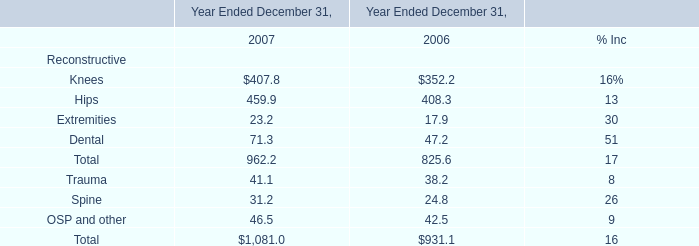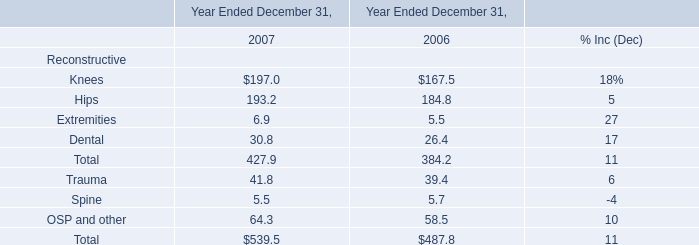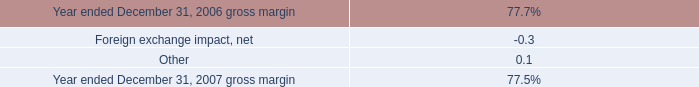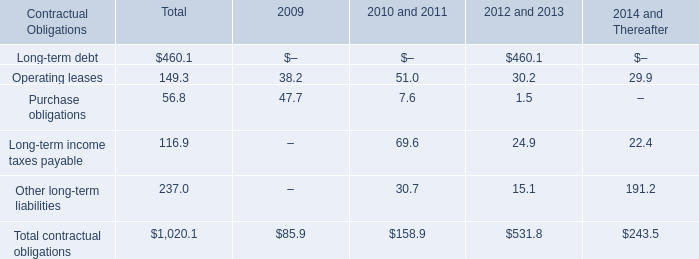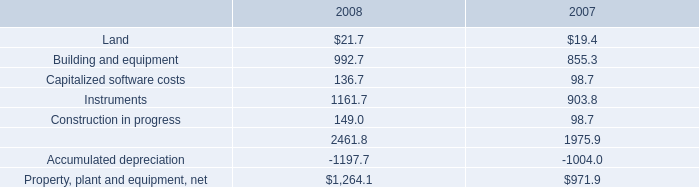what percent of total contractual obligations is due 2012 or after? 
Computations: ((531.8 + 243.5) / 1020.1)
Answer: 0.76002. 